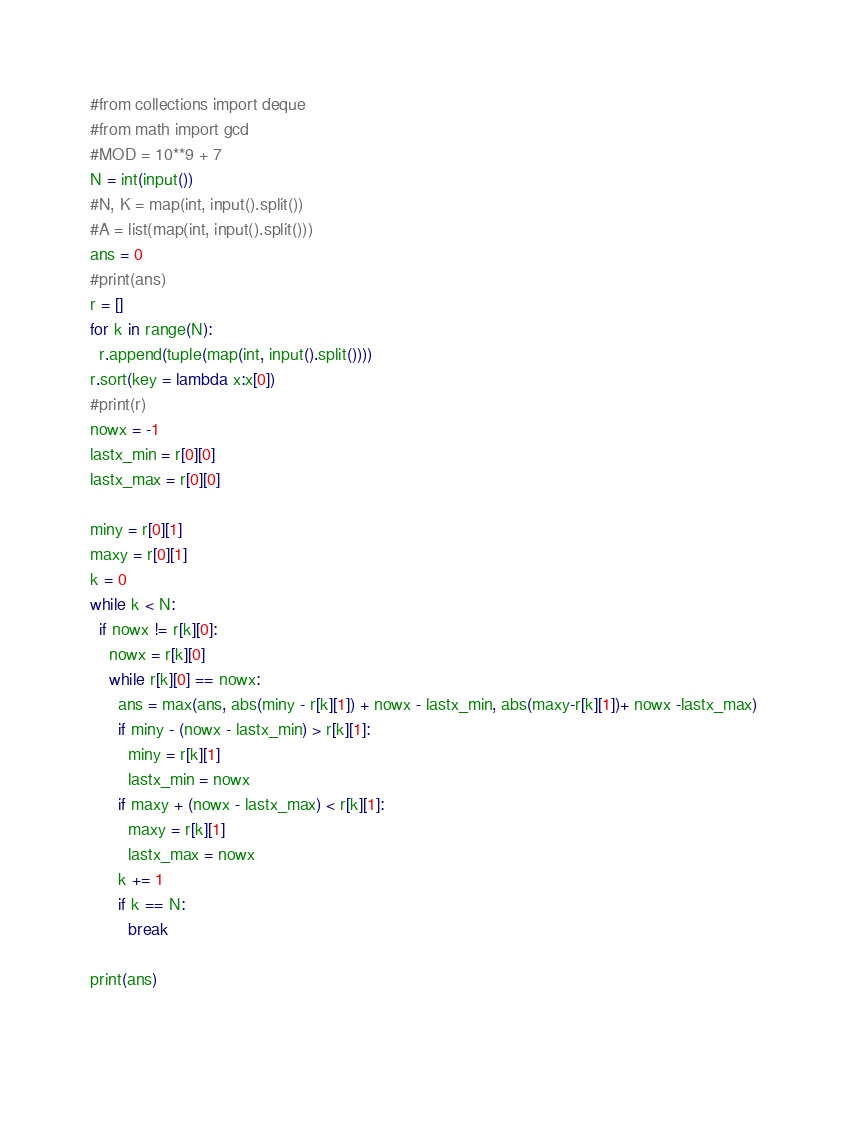<code> <loc_0><loc_0><loc_500><loc_500><_Python_>#from collections import deque
#from math import gcd
#MOD = 10**9 + 7
N = int(input())
#N, K = map(int, input().split())
#A = list(map(int, input().split()))
ans = 0
#print(ans)
r = []
for k in range(N):
  r.append(tuple(map(int, input().split())))
r.sort(key = lambda x:x[0])
#print(r)
nowx = -1
lastx_min = r[0][0]
lastx_max = r[0][0]

miny = r[0][1]
maxy = r[0][1]
k = 0
while k < N:
  if nowx != r[k][0]:
    nowx = r[k][0]
    while r[k][0] == nowx:
      ans = max(ans, abs(miny - r[k][1]) + nowx - lastx_min, abs(maxy-r[k][1])+ nowx -lastx_max)
      if miny - (nowx - lastx_min) > r[k][1]:
        miny = r[k][1]
        lastx_min = nowx
      if maxy + (nowx - lastx_max) < r[k][1]:
        maxy = r[k][1]
        lastx_max = nowx
      k += 1
      if k == N:
        break

print(ans)

    </code> 